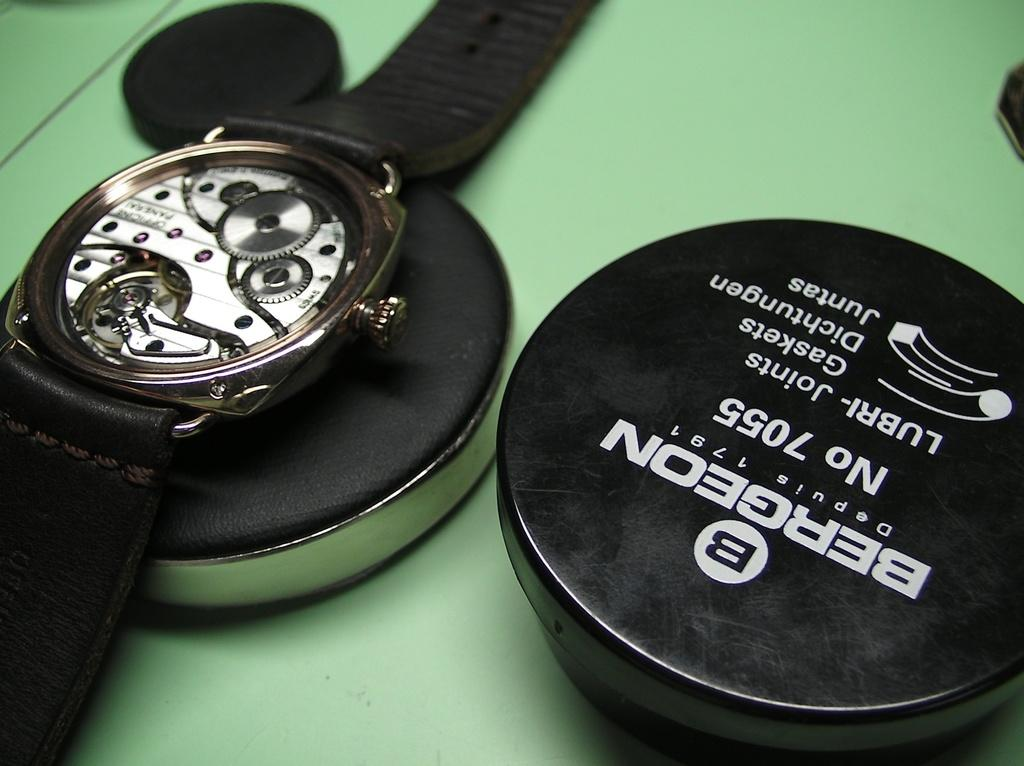<image>
Give a short and clear explanation of the subsequent image. A BERGEON watch NO 7055 has the back taken off of it 